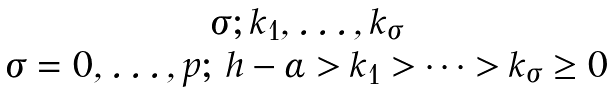<formula> <loc_0><loc_0><loc_500><loc_500>\begin{matrix} \sigma ; k _ { 1 } , \dots , k _ { \sigma } \\ \sigma = 0 , \dots , p ; \, h - \alpha > k _ { 1 } > \dots > k _ { \sigma } \geq 0 \end{matrix}</formula> 